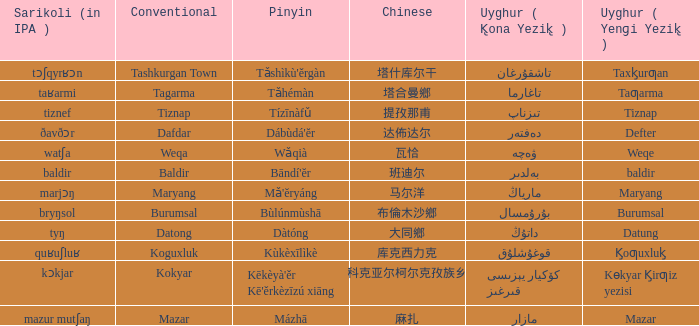Name the pinyin for تىزناپ Tízīnàfǔ. 